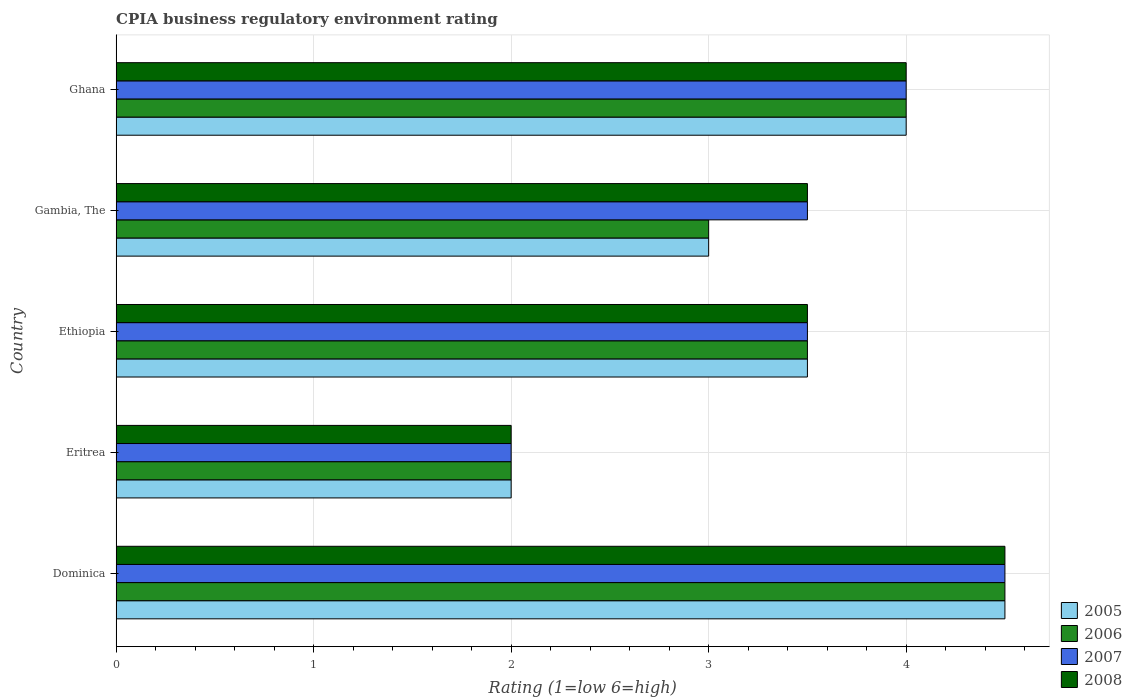Are the number of bars per tick equal to the number of legend labels?
Ensure brevity in your answer.  Yes. How many bars are there on the 5th tick from the bottom?
Give a very brief answer. 4. What is the label of the 4th group of bars from the top?
Ensure brevity in your answer.  Eritrea. In which country was the CPIA rating in 2008 maximum?
Give a very brief answer. Dominica. In which country was the CPIA rating in 2006 minimum?
Offer a very short reply. Eritrea. What is the total CPIA rating in 2005 in the graph?
Keep it short and to the point. 17. What is the difference between the CPIA rating in 2005 in Eritrea and that in Gambia, The?
Offer a terse response. -1. What is the difference between the CPIA rating in 2007 in Eritrea and the CPIA rating in 2005 in Gambia, The?
Your answer should be very brief. -1. What is the average CPIA rating in 2005 per country?
Provide a succinct answer. 3.4. What is the difference between the CPIA rating in 2007 and CPIA rating in 2006 in Dominica?
Provide a short and direct response. 0. What is the ratio of the CPIA rating in 2008 in Ethiopia to that in Gambia, The?
Offer a terse response. 1. Is the CPIA rating in 2005 in Ethiopia less than that in Gambia, The?
Give a very brief answer. No. Is the difference between the CPIA rating in 2007 in Eritrea and Ethiopia greater than the difference between the CPIA rating in 2006 in Eritrea and Ethiopia?
Keep it short and to the point. No. What is the difference between the highest and the second highest CPIA rating in 2006?
Ensure brevity in your answer.  0.5. In how many countries, is the CPIA rating in 2008 greater than the average CPIA rating in 2008 taken over all countries?
Your response must be concise. 2. Is it the case that in every country, the sum of the CPIA rating in 2005 and CPIA rating in 2007 is greater than the sum of CPIA rating in 2008 and CPIA rating in 2006?
Provide a succinct answer. No. What does the 3rd bar from the top in Gambia, The represents?
Keep it short and to the point. 2006. Are all the bars in the graph horizontal?
Ensure brevity in your answer.  Yes. How many countries are there in the graph?
Offer a terse response. 5. What is the difference between two consecutive major ticks on the X-axis?
Provide a short and direct response. 1. Does the graph contain grids?
Your answer should be very brief. Yes. What is the title of the graph?
Provide a short and direct response. CPIA business regulatory environment rating. What is the label or title of the X-axis?
Your response must be concise. Rating (1=low 6=high). What is the label or title of the Y-axis?
Your answer should be compact. Country. What is the Rating (1=low 6=high) of 2005 in Dominica?
Your response must be concise. 4.5. What is the Rating (1=low 6=high) of 2008 in Dominica?
Ensure brevity in your answer.  4.5. What is the Rating (1=low 6=high) in 2006 in Eritrea?
Your answer should be very brief. 2. What is the Rating (1=low 6=high) of 2007 in Eritrea?
Keep it short and to the point. 2. What is the Rating (1=low 6=high) in 2008 in Eritrea?
Keep it short and to the point. 2. What is the Rating (1=low 6=high) in 2005 in Ethiopia?
Your answer should be compact. 3.5. What is the Rating (1=low 6=high) of 2008 in Ethiopia?
Make the answer very short. 3.5. What is the Rating (1=low 6=high) of 2006 in Gambia, The?
Offer a very short reply. 3. What is the Rating (1=low 6=high) in 2008 in Gambia, The?
Give a very brief answer. 3.5. What is the Rating (1=low 6=high) of 2005 in Ghana?
Offer a very short reply. 4. Across all countries, what is the maximum Rating (1=low 6=high) in 2006?
Provide a succinct answer. 4.5. Across all countries, what is the minimum Rating (1=low 6=high) in 2007?
Ensure brevity in your answer.  2. Across all countries, what is the minimum Rating (1=low 6=high) of 2008?
Ensure brevity in your answer.  2. What is the total Rating (1=low 6=high) of 2006 in the graph?
Give a very brief answer. 17. What is the total Rating (1=low 6=high) in 2007 in the graph?
Offer a terse response. 17.5. What is the difference between the Rating (1=low 6=high) of 2005 in Dominica and that in Ethiopia?
Ensure brevity in your answer.  1. What is the difference between the Rating (1=low 6=high) of 2007 in Dominica and that in Ethiopia?
Your response must be concise. 1. What is the difference between the Rating (1=low 6=high) in 2008 in Dominica and that in Ethiopia?
Your answer should be very brief. 1. What is the difference between the Rating (1=low 6=high) of 2006 in Dominica and that in Gambia, The?
Give a very brief answer. 1.5. What is the difference between the Rating (1=low 6=high) of 2006 in Dominica and that in Ghana?
Your answer should be very brief. 0.5. What is the difference between the Rating (1=low 6=high) of 2007 in Dominica and that in Ghana?
Ensure brevity in your answer.  0.5. What is the difference between the Rating (1=low 6=high) of 2008 in Dominica and that in Ghana?
Your answer should be compact. 0.5. What is the difference between the Rating (1=low 6=high) in 2006 in Eritrea and that in Ethiopia?
Provide a succinct answer. -1.5. What is the difference between the Rating (1=low 6=high) of 2007 in Eritrea and that in Ethiopia?
Provide a short and direct response. -1.5. What is the difference between the Rating (1=low 6=high) of 2008 in Eritrea and that in Ethiopia?
Give a very brief answer. -1.5. What is the difference between the Rating (1=low 6=high) in 2005 in Eritrea and that in Gambia, The?
Your response must be concise. -1. What is the difference between the Rating (1=low 6=high) in 2007 in Eritrea and that in Gambia, The?
Your answer should be very brief. -1.5. What is the difference between the Rating (1=low 6=high) in 2008 in Eritrea and that in Gambia, The?
Offer a terse response. -1.5. What is the difference between the Rating (1=low 6=high) of 2007 in Eritrea and that in Ghana?
Ensure brevity in your answer.  -2. What is the difference between the Rating (1=low 6=high) in 2005 in Ethiopia and that in Gambia, The?
Provide a short and direct response. 0.5. What is the difference between the Rating (1=low 6=high) in 2006 in Ethiopia and that in Gambia, The?
Give a very brief answer. 0.5. What is the difference between the Rating (1=low 6=high) in 2005 in Ethiopia and that in Ghana?
Provide a succinct answer. -0.5. What is the difference between the Rating (1=low 6=high) in 2006 in Ethiopia and that in Ghana?
Make the answer very short. -0.5. What is the difference between the Rating (1=low 6=high) of 2007 in Ethiopia and that in Ghana?
Ensure brevity in your answer.  -0.5. What is the difference between the Rating (1=low 6=high) of 2007 in Gambia, The and that in Ghana?
Provide a short and direct response. -0.5. What is the difference between the Rating (1=low 6=high) of 2008 in Gambia, The and that in Ghana?
Ensure brevity in your answer.  -0.5. What is the difference between the Rating (1=low 6=high) of 2005 in Dominica and the Rating (1=low 6=high) of 2008 in Eritrea?
Your answer should be compact. 2.5. What is the difference between the Rating (1=low 6=high) in 2006 in Dominica and the Rating (1=low 6=high) in 2007 in Eritrea?
Make the answer very short. 2.5. What is the difference between the Rating (1=low 6=high) of 2007 in Dominica and the Rating (1=low 6=high) of 2008 in Eritrea?
Keep it short and to the point. 2.5. What is the difference between the Rating (1=low 6=high) of 2005 in Dominica and the Rating (1=low 6=high) of 2008 in Ethiopia?
Make the answer very short. 1. What is the difference between the Rating (1=low 6=high) of 2006 in Dominica and the Rating (1=low 6=high) of 2007 in Ethiopia?
Your response must be concise. 1. What is the difference between the Rating (1=low 6=high) in 2006 in Dominica and the Rating (1=low 6=high) in 2008 in Ethiopia?
Give a very brief answer. 1. What is the difference between the Rating (1=low 6=high) of 2007 in Dominica and the Rating (1=low 6=high) of 2008 in Ethiopia?
Ensure brevity in your answer.  1. What is the difference between the Rating (1=low 6=high) of 2007 in Dominica and the Rating (1=low 6=high) of 2008 in Gambia, The?
Give a very brief answer. 1. What is the difference between the Rating (1=low 6=high) of 2005 in Dominica and the Rating (1=low 6=high) of 2008 in Ghana?
Your answer should be compact. 0.5. What is the difference between the Rating (1=low 6=high) in 2006 in Dominica and the Rating (1=low 6=high) in 2007 in Ghana?
Provide a succinct answer. 0.5. What is the difference between the Rating (1=low 6=high) of 2007 in Dominica and the Rating (1=low 6=high) of 2008 in Ghana?
Give a very brief answer. 0.5. What is the difference between the Rating (1=low 6=high) of 2005 in Eritrea and the Rating (1=low 6=high) of 2008 in Ethiopia?
Your answer should be compact. -1.5. What is the difference between the Rating (1=low 6=high) of 2006 in Eritrea and the Rating (1=low 6=high) of 2007 in Ethiopia?
Offer a very short reply. -1.5. What is the difference between the Rating (1=low 6=high) in 2005 in Eritrea and the Rating (1=low 6=high) in 2006 in Gambia, The?
Offer a very short reply. -1. What is the difference between the Rating (1=low 6=high) in 2006 in Eritrea and the Rating (1=low 6=high) in 2007 in Gambia, The?
Your answer should be very brief. -1.5. What is the difference between the Rating (1=low 6=high) of 2006 in Eritrea and the Rating (1=low 6=high) of 2008 in Gambia, The?
Offer a terse response. -1.5. What is the difference between the Rating (1=low 6=high) in 2005 in Eritrea and the Rating (1=low 6=high) in 2006 in Ghana?
Keep it short and to the point. -2. What is the difference between the Rating (1=low 6=high) of 2005 in Eritrea and the Rating (1=low 6=high) of 2007 in Ghana?
Give a very brief answer. -2. What is the difference between the Rating (1=low 6=high) of 2005 in Eritrea and the Rating (1=low 6=high) of 2008 in Ghana?
Your answer should be very brief. -2. What is the difference between the Rating (1=low 6=high) in 2006 in Eritrea and the Rating (1=low 6=high) in 2007 in Ghana?
Ensure brevity in your answer.  -2. What is the difference between the Rating (1=low 6=high) of 2005 in Ethiopia and the Rating (1=low 6=high) of 2008 in Gambia, The?
Give a very brief answer. 0. What is the difference between the Rating (1=low 6=high) in 2006 in Ethiopia and the Rating (1=low 6=high) in 2008 in Gambia, The?
Offer a terse response. 0. What is the difference between the Rating (1=low 6=high) in 2005 in Ethiopia and the Rating (1=low 6=high) in 2006 in Ghana?
Offer a very short reply. -0.5. What is the difference between the Rating (1=low 6=high) of 2005 in Ethiopia and the Rating (1=low 6=high) of 2007 in Ghana?
Make the answer very short. -0.5. What is the difference between the Rating (1=low 6=high) of 2005 in Ethiopia and the Rating (1=low 6=high) of 2008 in Ghana?
Offer a terse response. -0.5. What is the difference between the Rating (1=low 6=high) in 2006 in Ethiopia and the Rating (1=low 6=high) in 2007 in Ghana?
Provide a succinct answer. -0.5. What is the difference between the Rating (1=low 6=high) in 2007 in Ethiopia and the Rating (1=low 6=high) in 2008 in Ghana?
Ensure brevity in your answer.  -0.5. What is the difference between the Rating (1=low 6=high) of 2005 in Gambia, The and the Rating (1=low 6=high) of 2006 in Ghana?
Ensure brevity in your answer.  -1. What is the difference between the Rating (1=low 6=high) of 2005 in Gambia, The and the Rating (1=low 6=high) of 2007 in Ghana?
Your response must be concise. -1. What is the difference between the Rating (1=low 6=high) of 2006 in Gambia, The and the Rating (1=low 6=high) of 2007 in Ghana?
Give a very brief answer. -1. What is the difference between the Rating (1=low 6=high) in 2007 in Gambia, The and the Rating (1=low 6=high) in 2008 in Ghana?
Provide a succinct answer. -0.5. What is the average Rating (1=low 6=high) of 2005 per country?
Your answer should be compact. 3.4. What is the average Rating (1=low 6=high) of 2007 per country?
Provide a short and direct response. 3.5. What is the difference between the Rating (1=low 6=high) of 2005 and Rating (1=low 6=high) of 2006 in Dominica?
Your answer should be compact. 0. What is the difference between the Rating (1=low 6=high) in 2005 and Rating (1=low 6=high) in 2007 in Dominica?
Ensure brevity in your answer.  0. What is the difference between the Rating (1=low 6=high) in 2006 and Rating (1=low 6=high) in 2008 in Dominica?
Provide a succinct answer. 0. What is the difference between the Rating (1=low 6=high) in 2005 and Rating (1=low 6=high) in 2006 in Eritrea?
Provide a succinct answer. 0. What is the difference between the Rating (1=low 6=high) of 2007 and Rating (1=low 6=high) of 2008 in Eritrea?
Make the answer very short. 0. What is the difference between the Rating (1=low 6=high) in 2005 and Rating (1=low 6=high) in 2006 in Ethiopia?
Keep it short and to the point. 0. What is the difference between the Rating (1=low 6=high) in 2005 and Rating (1=low 6=high) in 2007 in Ethiopia?
Give a very brief answer. 0. What is the difference between the Rating (1=low 6=high) of 2006 and Rating (1=low 6=high) of 2007 in Ethiopia?
Give a very brief answer. 0. What is the difference between the Rating (1=low 6=high) in 2006 and Rating (1=low 6=high) in 2008 in Ethiopia?
Provide a succinct answer. 0. What is the difference between the Rating (1=low 6=high) of 2007 and Rating (1=low 6=high) of 2008 in Ethiopia?
Offer a terse response. 0. What is the difference between the Rating (1=low 6=high) of 2006 and Rating (1=low 6=high) of 2007 in Gambia, The?
Your answer should be very brief. -0.5. What is the difference between the Rating (1=low 6=high) in 2005 and Rating (1=low 6=high) in 2006 in Ghana?
Make the answer very short. 0. What is the difference between the Rating (1=low 6=high) in 2005 and Rating (1=low 6=high) in 2007 in Ghana?
Offer a very short reply. 0. What is the difference between the Rating (1=low 6=high) of 2005 and Rating (1=low 6=high) of 2008 in Ghana?
Your response must be concise. 0. What is the difference between the Rating (1=low 6=high) of 2006 and Rating (1=low 6=high) of 2008 in Ghana?
Provide a succinct answer. 0. What is the difference between the Rating (1=low 6=high) in 2007 and Rating (1=low 6=high) in 2008 in Ghana?
Give a very brief answer. 0. What is the ratio of the Rating (1=low 6=high) in 2005 in Dominica to that in Eritrea?
Give a very brief answer. 2.25. What is the ratio of the Rating (1=low 6=high) in 2006 in Dominica to that in Eritrea?
Keep it short and to the point. 2.25. What is the ratio of the Rating (1=low 6=high) of 2007 in Dominica to that in Eritrea?
Provide a short and direct response. 2.25. What is the ratio of the Rating (1=low 6=high) in 2008 in Dominica to that in Eritrea?
Make the answer very short. 2.25. What is the ratio of the Rating (1=low 6=high) of 2006 in Dominica to that in Ethiopia?
Offer a very short reply. 1.29. What is the ratio of the Rating (1=low 6=high) in 2008 in Dominica to that in Gambia, The?
Make the answer very short. 1.29. What is the ratio of the Rating (1=low 6=high) in 2005 in Eritrea to that in Ethiopia?
Offer a very short reply. 0.57. What is the ratio of the Rating (1=low 6=high) in 2007 in Eritrea to that in Ethiopia?
Offer a very short reply. 0.57. What is the ratio of the Rating (1=low 6=high) of 2005 in Eritrea to that in Gambia, The?
Offer a terse response. 0.67. What is the ratio of the Rating (1=low 6=high) of 2007 in Eritrea to that in Gambia, The?
Your answer should be compact. 0.57. What is the ratio of the Rating (1=low 6=high) of 2006 in Eritrea to that in Ghana?
Give a very brief answer. 0.5. What is the ratio of the Rating (1=low 6=high) of 2008 in Eritrea to that in Ghana?
Your answer should be very brief. 0.5. What is the ratio of the Rating (1=low 6=high) in 2005 in Ethiopia to that in Gambia, The?
Give a very brief answer. 1.17. What is the ratio of the Rating (1=low 6=high) in 2006 in Ethiopia to that in Gambia, The?
Make the answer very short. 1.17. What is the ratio of the Rating (1=low 6=high) of 2007 in Ethiopia to that in Gambia, The?
Your answer should be compact. 1. What is the ratio of the Rating (1=low 6=high) in 2007 in Gambia, The to that in Ghana?
Keep it short and to the point. 0.88. What is the difference between the highest and the second highest Rating (1=low 6=high) of 2005?
Provide a succinct answer. 0.5. What is the difference between the highest and the second highest Rating (1=low 6=high) of 2008?
Your answer should be compact. 0.5. What is the difference between the highest and the lowest Rating (1=low 6=high) in 2005?
Offer a very short reply. 2.5. What is the difference between the highest and the lowest Rating (1=low 6=high) of 2006?
Your answer should be compact. 2.5. What is the difference between the highest and the lowest Rating (1=low 6=high) of 2008?
Your answer should be compact. 2.5. 